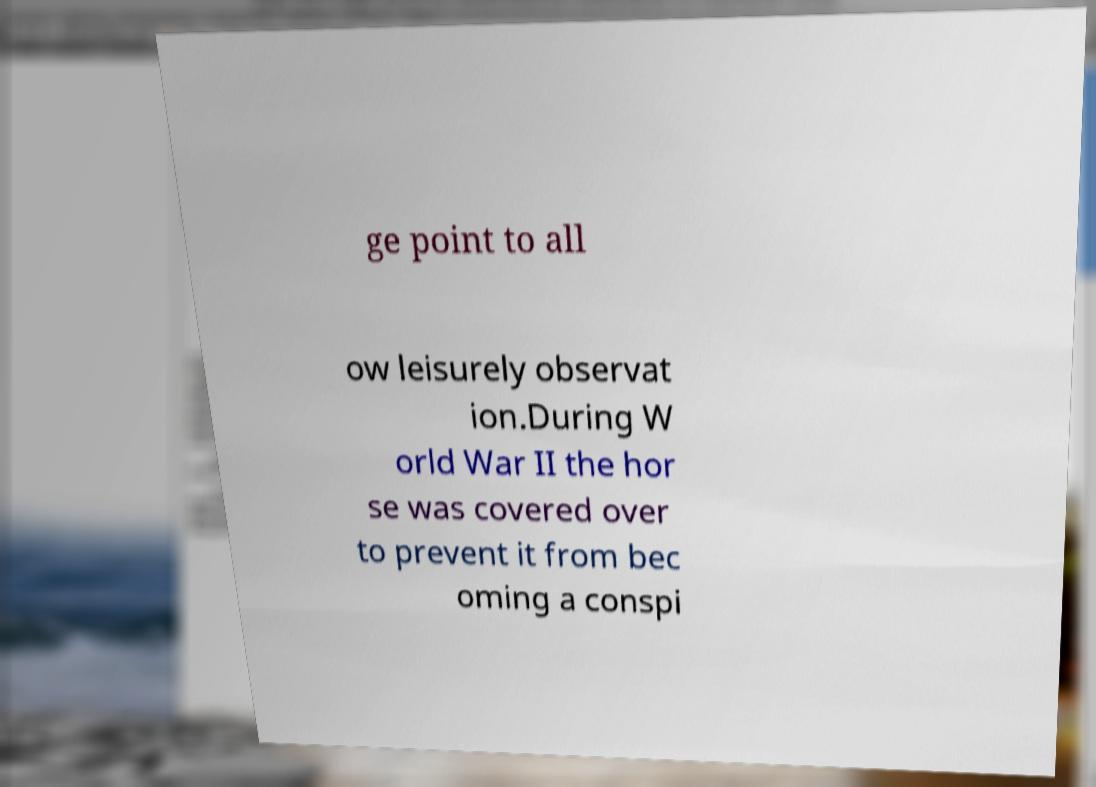Please read and relay the text visible in this image. What does it say? ge point to all ow leisurely observat ion.During W orld War II the hor se was covered over to prevent it from bec oming a conspi 